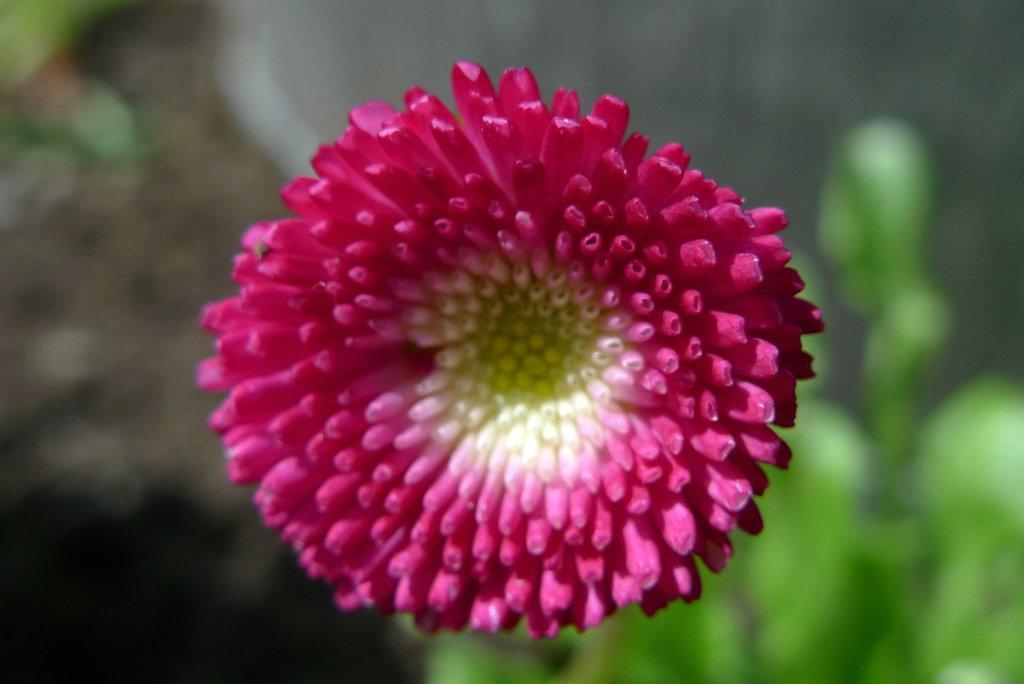What is the main subject of the image? There is a flower in the image. What color is the flower? The flower is pink in color. Where is the flower located in the image? The flower is in the middle of the image. How many dimes are placed around the flower in the image? There are no dimes present in the image; it only features a pink flower in the middle. What type of respect can be seen in the image? There is no indication of respect or any related actions in the image, as it only contains a pink flower. 